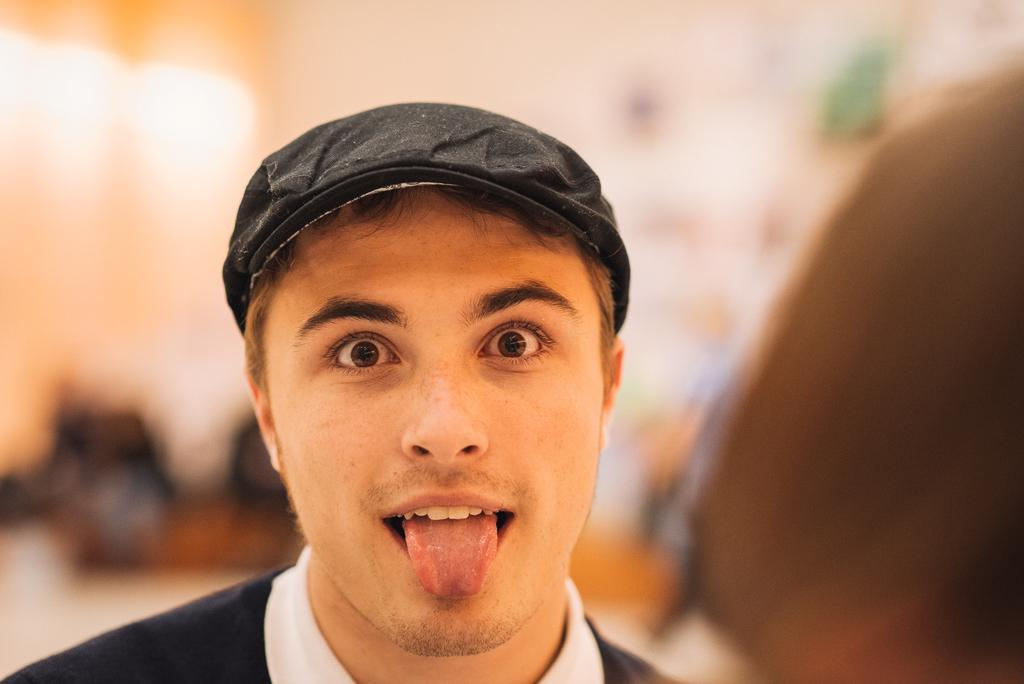Who is present in the image? There is a man in the image. What is the man wearing in the image? The man is wearing a black jacket. Can you describe the background of the image? The background of the image is blurred. What language is the man speaking in the image? There is no indication of the man speaking in the image, nor is there any information about the language he might be speaking. 